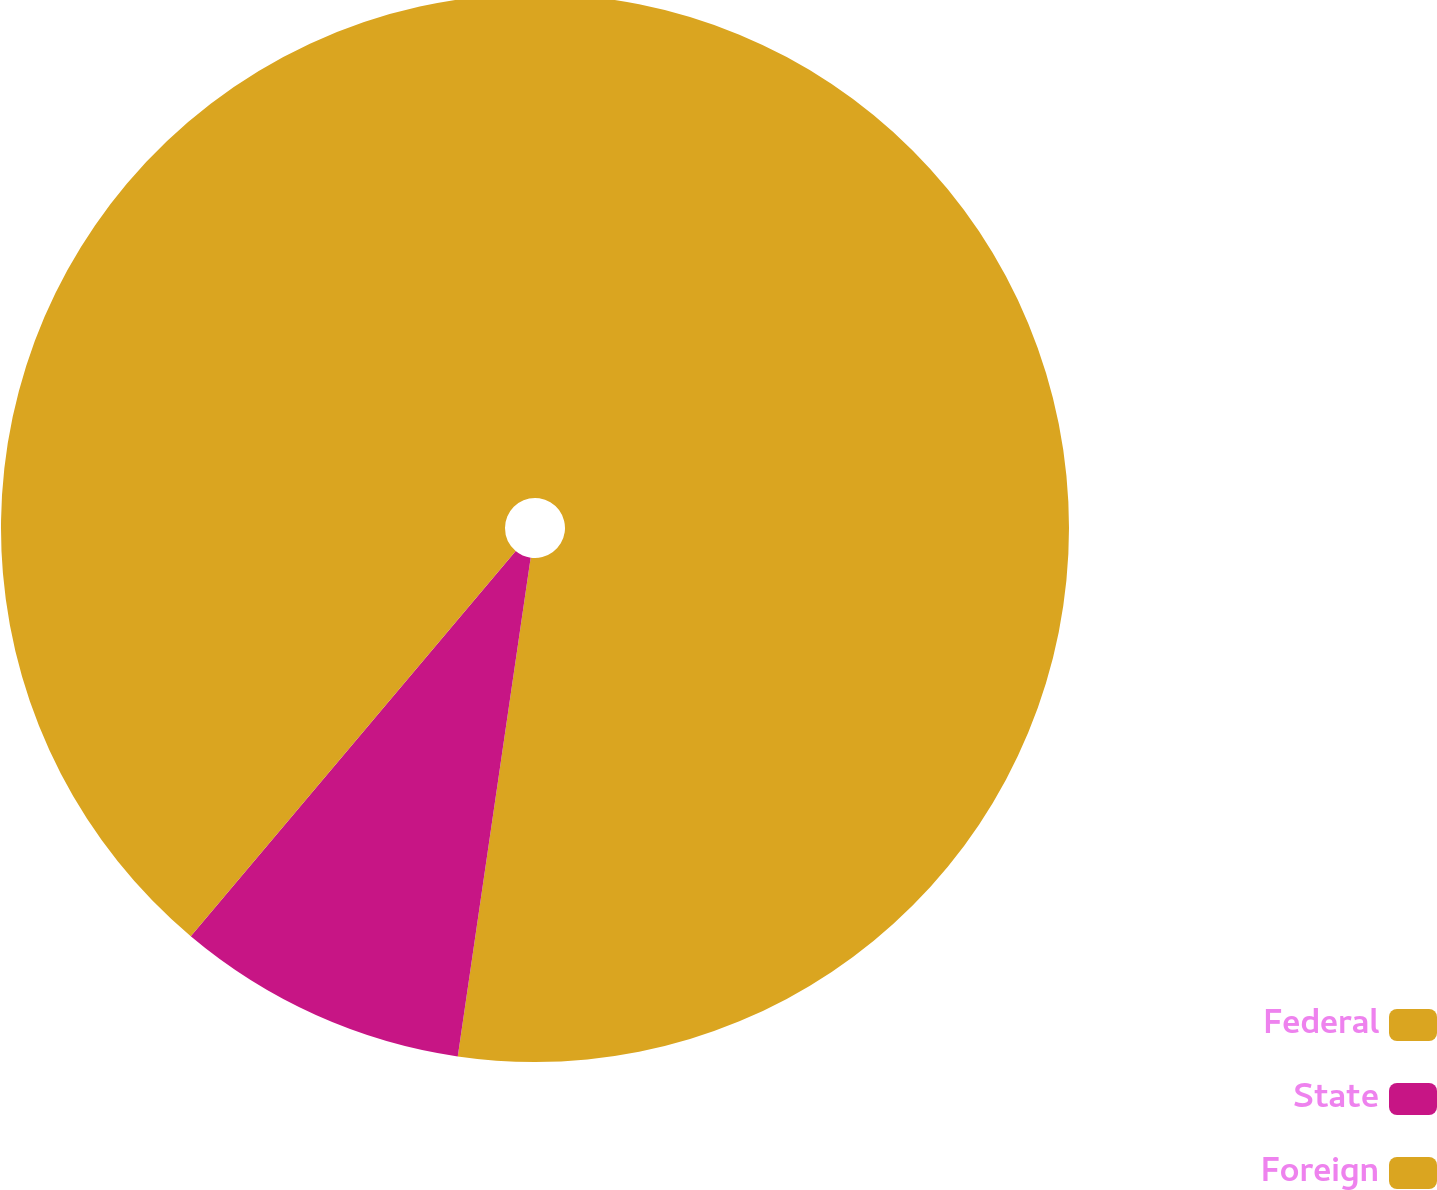<chart> <loc_0><loc_0><loc_500><loc_500><pie_chart><fcel>Federal<fcel>State<fcel>Foreign<nl><fcel>52.31%<fcel>8.84%<fcel>38.85%<nl></chart> 